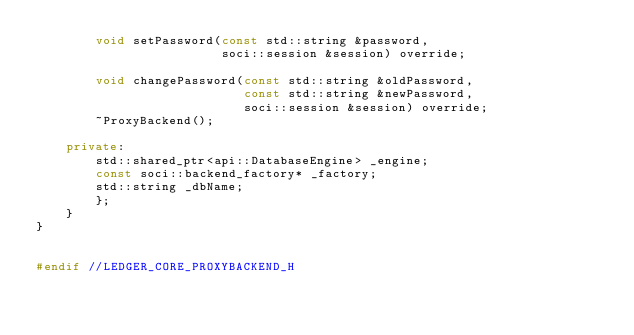<code> <loc_0><loc_0><loc_500><loc_500><_C++_>        void setPassword(const std::string &password,
                         soci::session &session) override;

        void changePassword(const std::string &oldPassword,
                            const std::string &newPassword,
                            soci::session &session) override;
        ~ProxyBackend();

    private:
        std::shared_ptr<api::DatabaseEngine> _engine;
        const soci::backend_factory* _factory;
        std::string _dbName;
        };
    }
}


#endif //LEDGER_CORE_PROXYBACKEND_H
</code> 